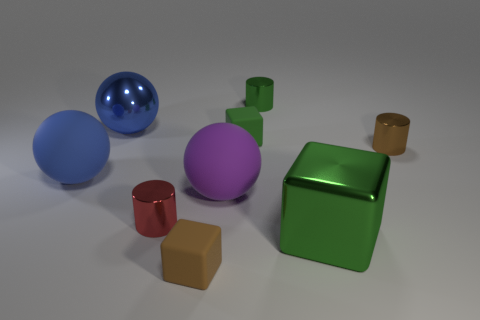Add 1 small things. How many objects exist? 10 Subtract all balls. How many objects are left? 6 Add 1 red objects. How many red objects are left? 2 Add 6 shiny cylinders. How many shiny cylinders exist? 9 Subtract 0 blue cylinders. How many objects are left? 9 Subtract all spheres. Subtract all tiny balls. How many objects are left? 6 